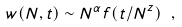<formula> <loc_0><loc_0><loc_500><loc_500>w ( N , t ) \sim N ^ { \alpha } f ( t / N ^ { z } ) \ ,</formula> 